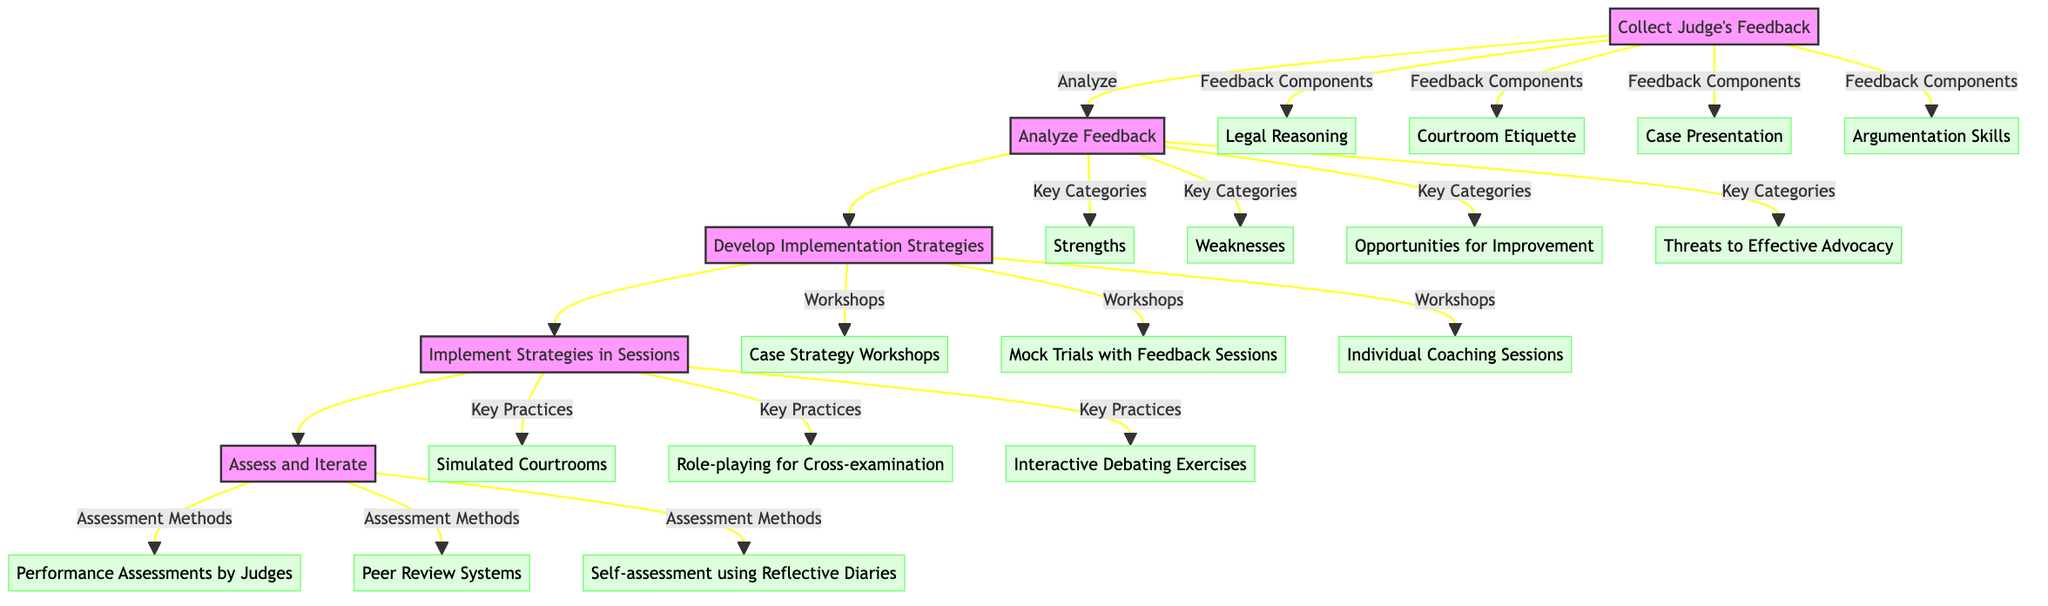What is the first stage in the pathway? The diagram indicates that the first stage is “Collect Judge's Feedback,” as it is the initial node in the clinical pathway.
Answer: Collect Judge's Feedback How many key practices are outlined in the implementation stage? By examining the “Implement Strategies in Sessions” stage, there are three key practices listed: Simulated Courtrooms, Role-playing for Cross-examination, and Interactive Debating Exercises.
Answer: 3 Which feedback component relates to presentation skills? The diagram lists "Case Presentation" as one of the feedback components provided by judges, indicating that it relates directly to presentation skills in mock court scenarios.
Answer: Case Presentation What are the key categories analyzed in the feedback stage? The diagram details four key categories in the “Analyze Feedback” stage: Strengths, Weaknesses, Opportunities for Improvement, and Threats to Effective Advocacy.
Answer: 4 Which stage involves creating actionable strategies? The “Develop Implementation Strategies” stage is responsible for creating actionable strategies based on prioritized feedback gathered from judges, as shown by its placement in the flow.
Answer: Develop Implementation Strategies What assessment methods are included in the final stage? The “Assess and Iterate” stage includes three assessment methods: Performance Assessments by Judges, Peer Review Systems, and Self-assessment using Reflective Diaries, indicating a robust evaluation process.
Answer: 3 What type of feedback form do judges use? The diagram specifies that judges provide detailed feedback using "standardized feedback forms," highlighting the structured approach taken for feedback.
Answer: Standardized feedback forms Which workshops are included in the strategy development stage? The strategy development stage outlines three specific workshops: Case Strategy Workshops, Mock Trials with Feedback Sessions, and Individual Coaching Sessions. This categorization emphasizes the organized approach to utilizing feedback.
Answer: 3 